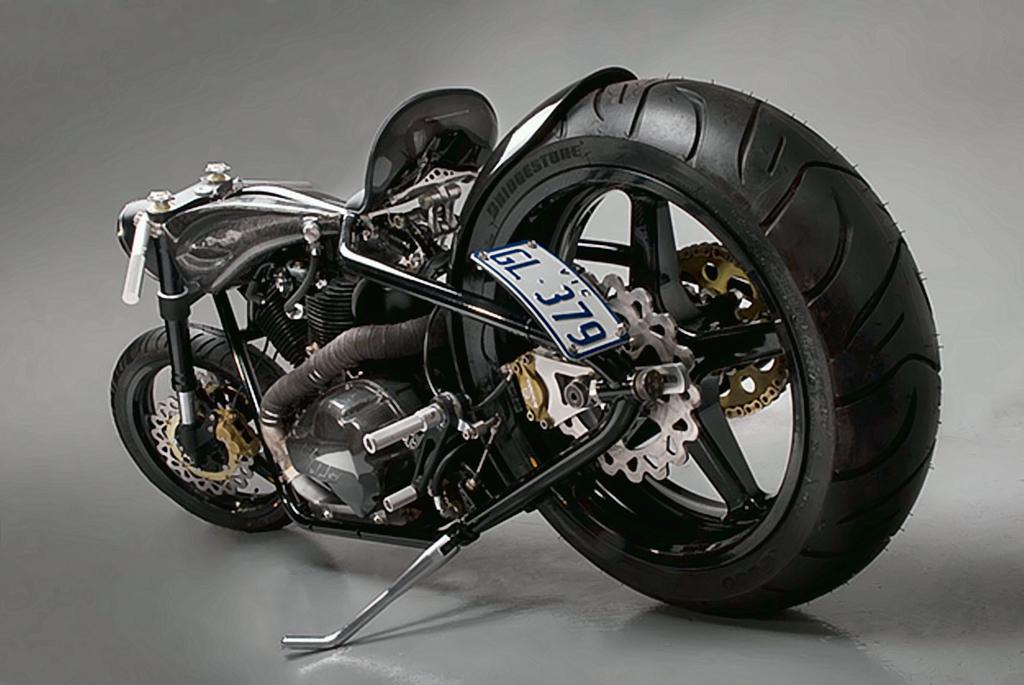What is the main subject of the image? The main subject of the image is a motorbike. Where is the motorbike located in the image? The motorbike is in the center of the image. What is the position of the motorbike in the image? The motorbike is on the floor. What type of pig can be seen in the bedroom in the image? There is no pig or bedroom present in the image; it features a motorbike on the floor. 